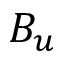Convert formula to latex. <formula><loc_0><loc_0><loc_500><loc_500>B _ { u }</formula> 